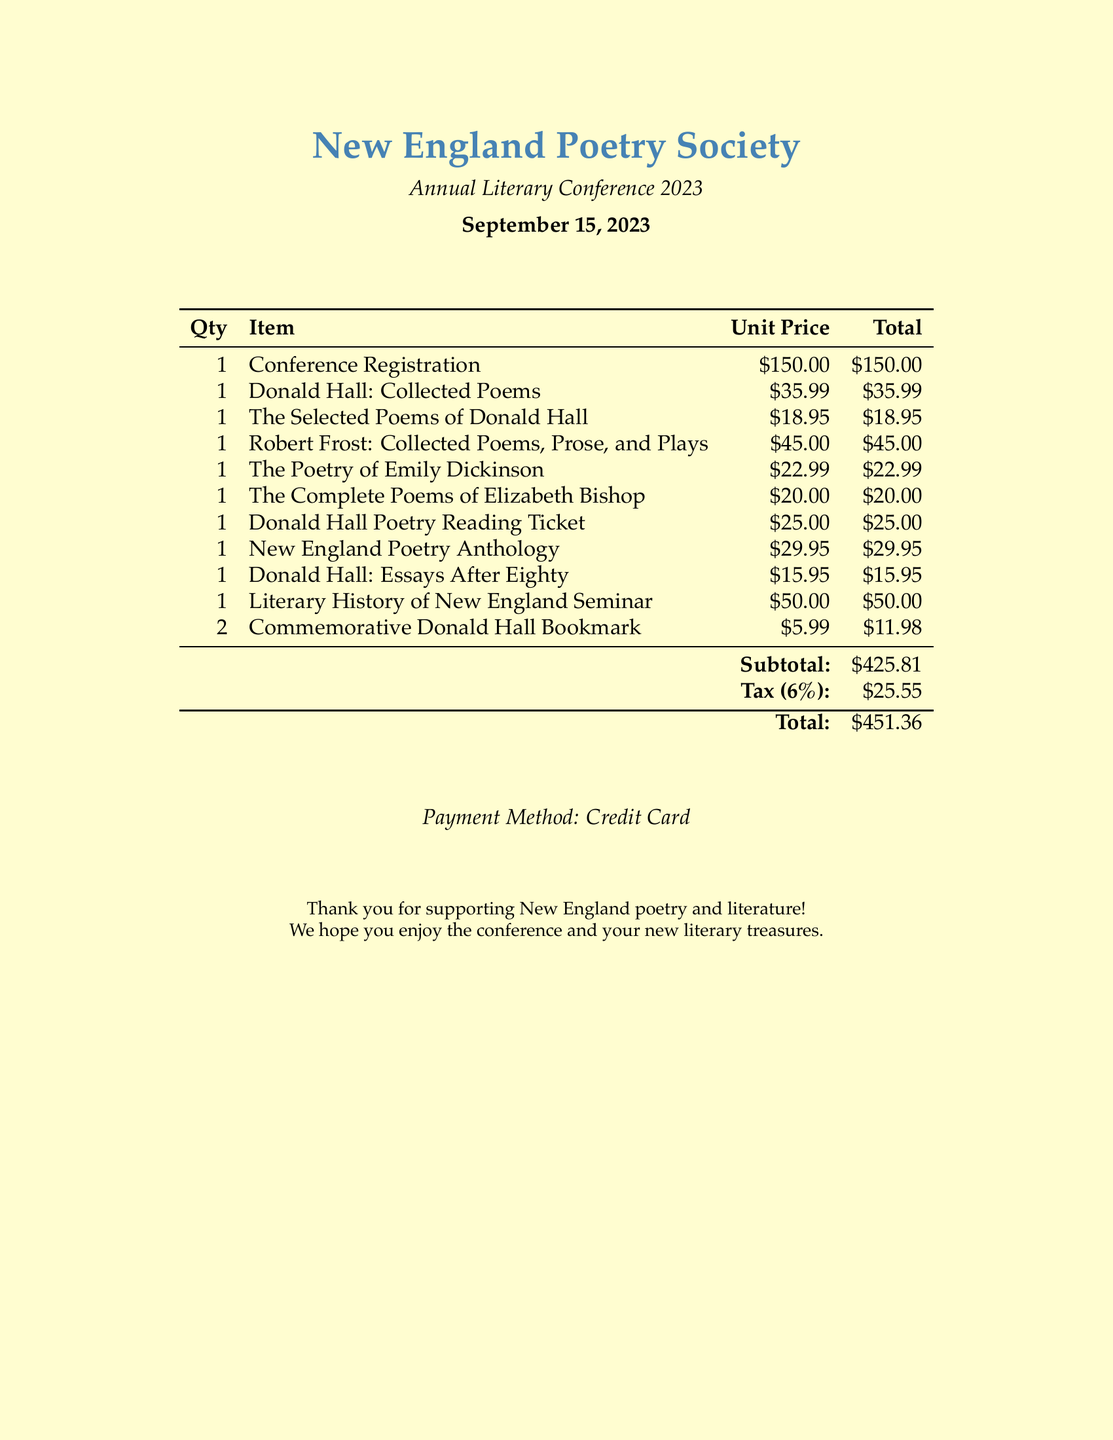What is the name of the store? The store is identified as "New England Poetry Society" in the document.
Answer: New England Poetry Society What is the date of the conference? The document specifies the date of the event as September 15, 2023.
Answer: September 15, 2023 How much is the ticket for the Donald Hall Poetry Reading? The ticket price for the Donald Hall Poetry Reading is listed in the document as $25.00.
Answer: $25.00 What is the total amount spent on the purchase? The total amount spent is indicated as $451.36 in the summary section of the receipt.
Answer: $451.36 Which poet's works were specifically highlighted in the document? The poets whose works were highlighted include Donald Hall, Robert Frost, Emily Dickinson, and Elizabeth Bishop.
Answer: Donald Hall How many commemorative bookmarks were purchased? The number of commemorative bookmarks purchased can be found in the document and is stated as 2.
Answer: 2 What was the subtotal before tax? The subtotal, which is before tax, is explicitly mentioned as $425.81.
Answer: $425.81 What payment method was used? The payment method for the purchase is indicated as "Credit Card."
Answer: Credit Card What is the tax rate applied to the purchase? The tax rate applied is noted as 6% in the calculation of the total.
Answer: 6% 